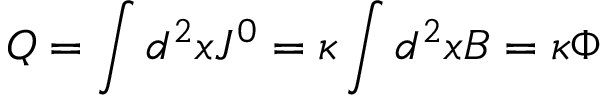Convert formula to latex. <formula><loc_0><loc_0><loc_500><loc_500>Q = \int d ^ { 2 } x J ^ { 0 } = \kappa \int d ^ { 2 } x B = \kappa \Phi</formula> 